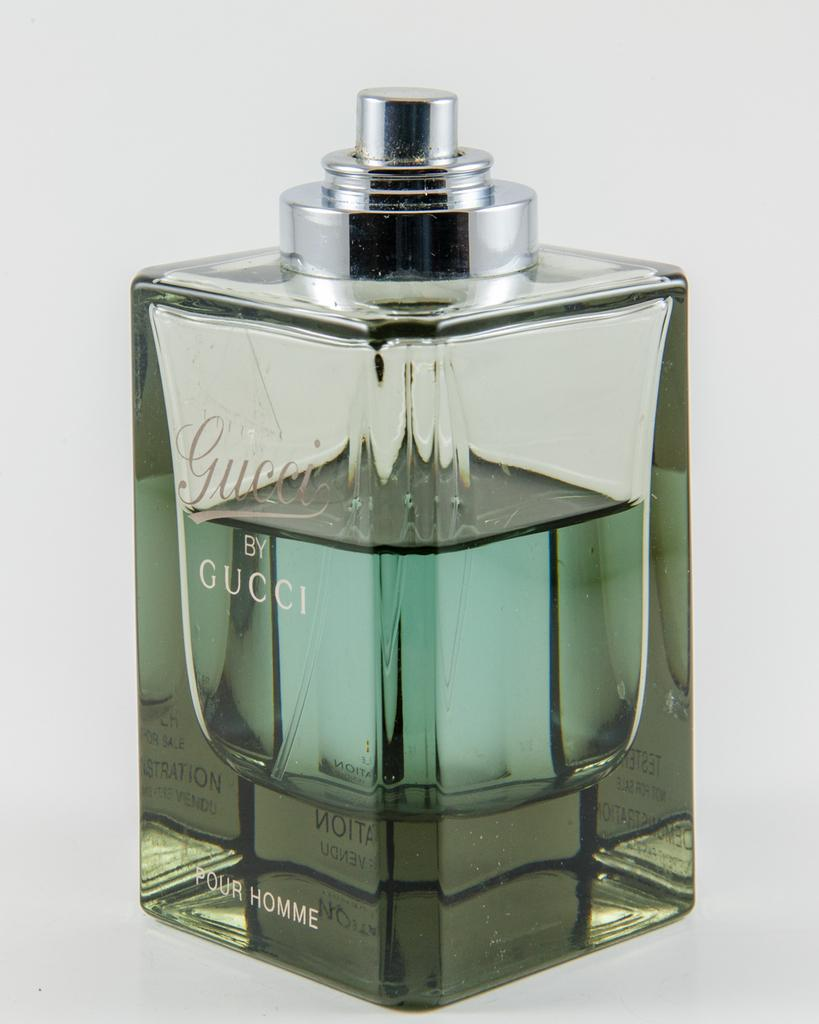<image>
Summarize the visual content of the image. A bottle of Gucci cologne appears to be bluish green in color. 